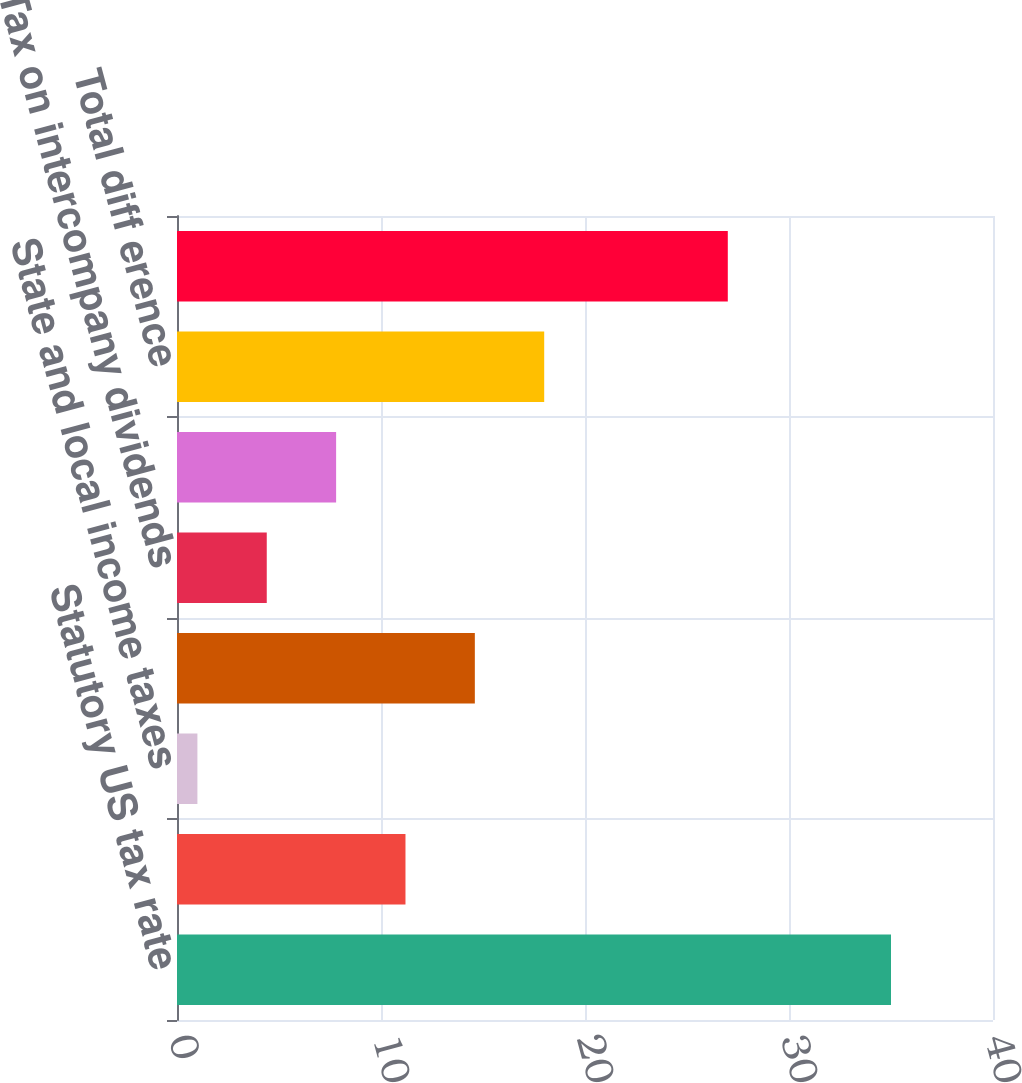Convert chart to OTSL. <chart><loc_0><loc_0><loc_500><loc_500><bar_chart><fcel>Statutory US tax rate<fcel>Percentage depletion<fcel>State and local income taxes<fcel>Foreign earnings subject to<fcel>Tax on intercompany dividends<fcel>Changes to unrecognized tax<fcel>Total diff erence<fcel>Effective tax rate<nl><fcel>35<fcel>11.2<fcel>1<fcel>14.6<fcel>4.4<fcel>7.8<fcel>18<fcel>27<nl></chart> 